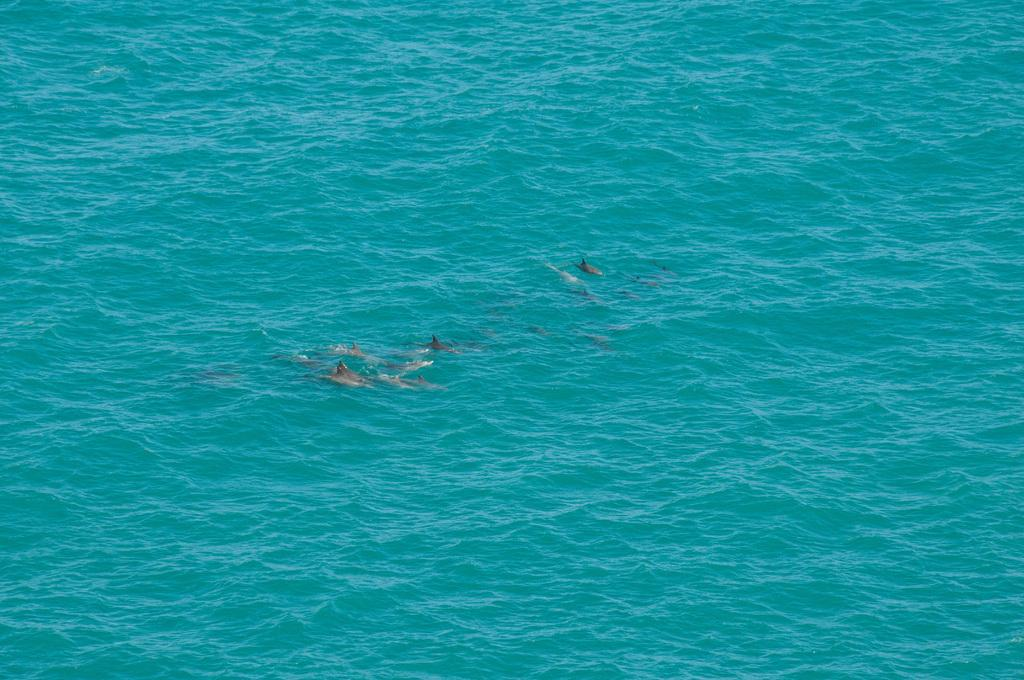What is the color of the sea in the image? The sea in the image is blue. What can be found in the sea? There are fishes in the sea. What type of headphones can be seen on the fishes in the image? There are no headphones present in the image; it features a blue sea with fishes. What kind of business is being conducted in the image? There is no business activity depicted in the image; it features a blue sea with fishes. 